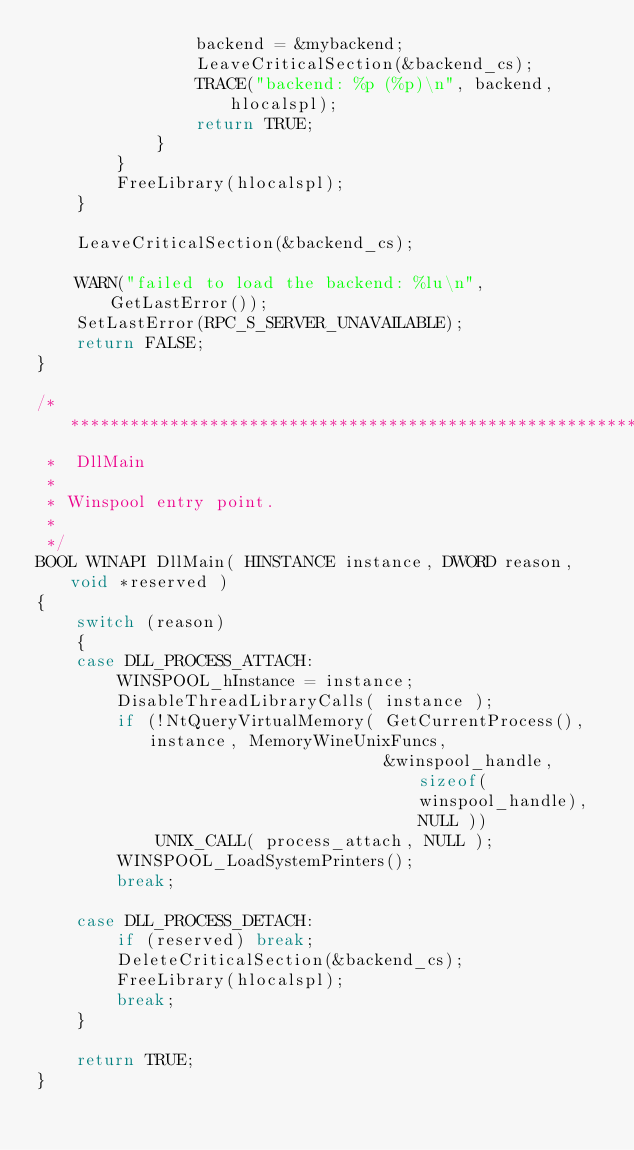<code> <loc_0><loc_0><loc_500><loc_500><_C_>                backend = &mybackend;
                LeaveCriticalSection(&backend_cs);
                TRACE("backend: %p (%p)\n", backend, hlocalspl);
                return TRUE;
            }
        }
        FreeLibrary(hlocalspl);
    }

    LeaveCriticalSection(&backend_cs);

    WARN("failed to load the backend: %lu\n", GetLastError());
    SetLastError(RPC_S_SERVER_UNAVAILABLE);
    return FALSE;
}

/******************************************************************************
 *  DllMain
 *
 * Winspool entry point.
 *
 */
BOOL WINAPI DllMain( HINSTANCE instance, DWORD reason, void *reserved )
{
    switch (reason)
    {
    case DLL_PROCESS_ATTACH:
        WINSPOOL_hInstance = instance;
        DisableThreadLibraryCalls( instance );
        if (!NtQueryVirtualMemory( GetCurrentProcess(), instance, MemoryWineUnixFuncs,
                                   &winspool_handle, sizeof(winspool_handle), NULL ))
            UNIX_CALL( process_attach, NULL );
        WINSPOOL_LoadSystemPrinters();
        break;

    case DLL_PROCESS_DETACH:
        if (reserved) break;
        DeleteCriticalSection(&backend_cs);
        FreeLibrary(hlocalspl);
        break;
    }

    return TRUE;
}
</code> 